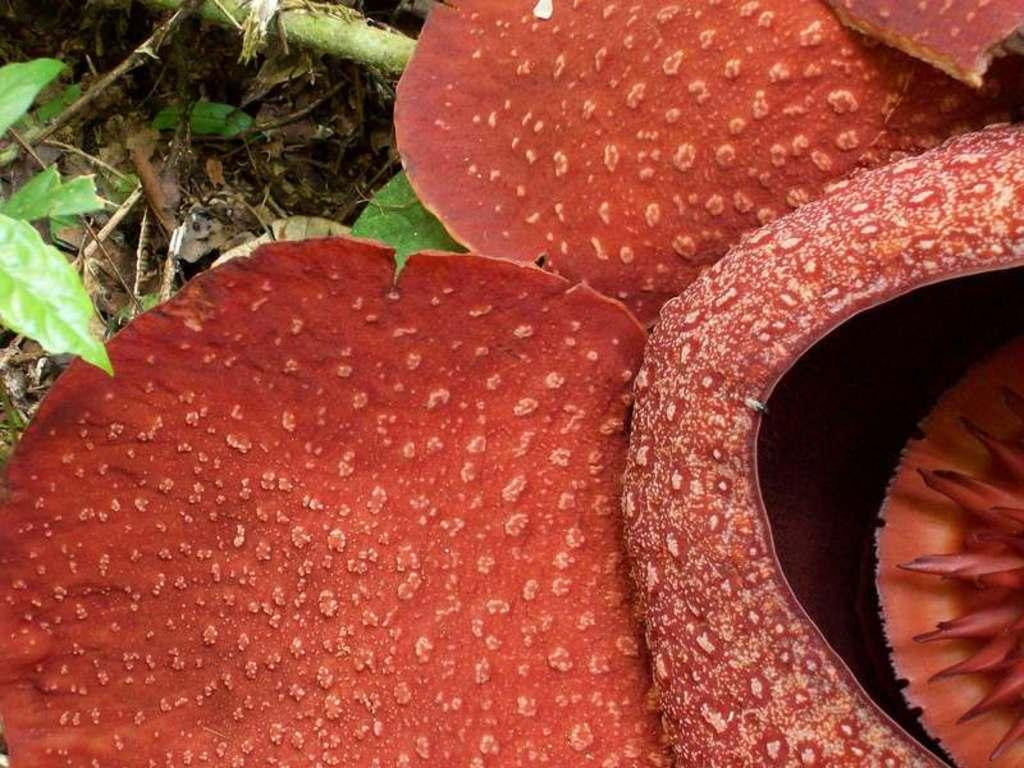What type of plants are visible in the image? There are house plants in the image. What type of vegetation is on the ground in the image? There is grass on the ground in the image. Can you determine the time of day the image was taken? The image was likely taken during the day, as there is sufficient light to see the plants and grass clearly. What type of net is being used to catch the tongue in the image? There is no net or tongue present in the image; it features house plants and grass. 